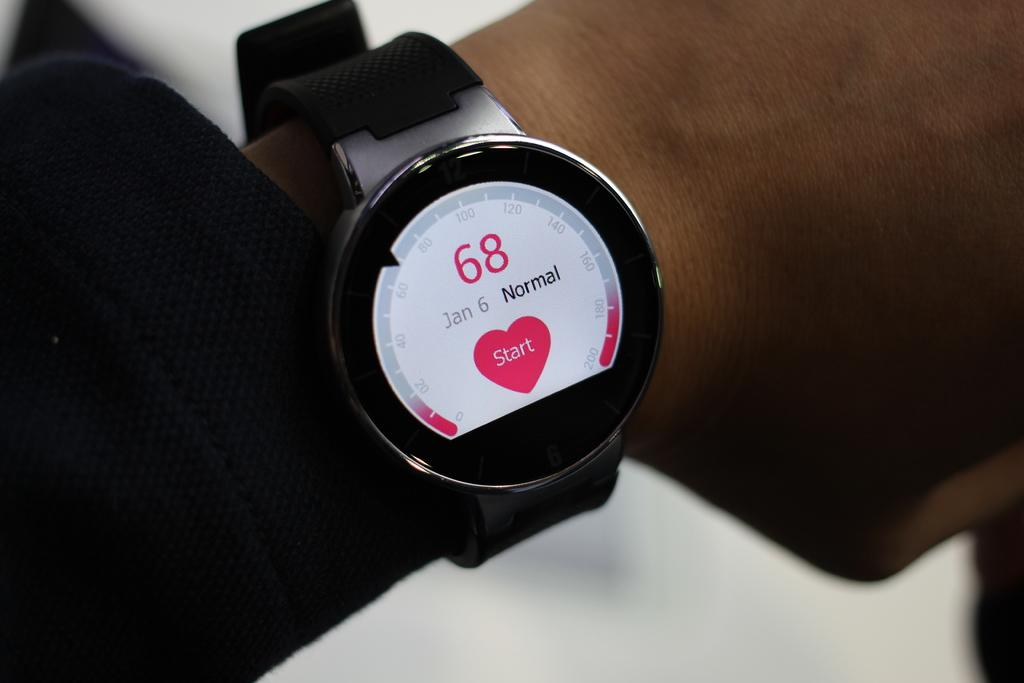Provide a one-sentence caption for the provided image. A smart watch the number 68 and a pink heart that says start in the middle in on somebody's wrist. 